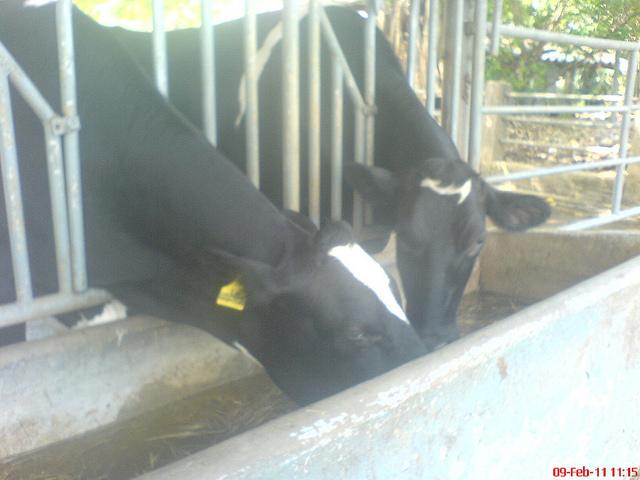What are the cow's drinking?
Answer briefly. Water. Are the cows young?
Quick response, please. No. What color are the cows?
Give a very brief answer. Black. 